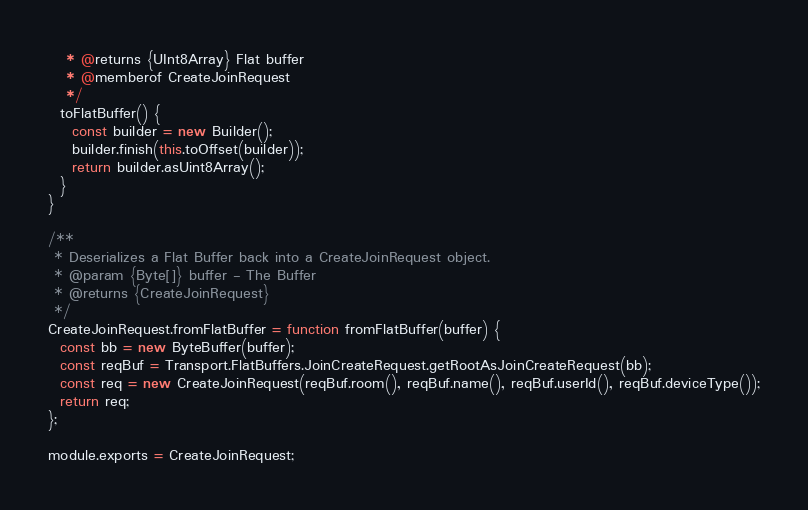Convert code to text. <code><loc_0><loc_0><loc_500><loc_500><_JavaScript_>   * @returns {UInt8Array} Flat buffer
   * @memberof CreateJoinRequest
   */
  toFlatBuffer() {
    const builder = new Builder();
    builder.finish(this.toOffset(builder));
    return builder.asUint8Array();
  }
}

/**
 * Deserializes a Flat Buffer back into a CreateJoinRequest object.
 * @param {Byte[]} buffer - The Buffer
 * @returns {CreateJoinRequest}
 */
CreateJoinRequest.fromFlatBuffer = function fromFlatBuffer(buffer) {
  const bb = new ByteBuffer(buffer);
  const reqBuf = Transport.FlatBuffers.JoinCreateRequest.getRootAsJoinCreateRequest(bb);
  const req = new CreateJoinRequest(reqBuf.room(), reqBuf.name(), reqBuf.userId(), reqBuf.deviceType());
  return req;
};

module.exports = CreateJoinRequest;
</code> 